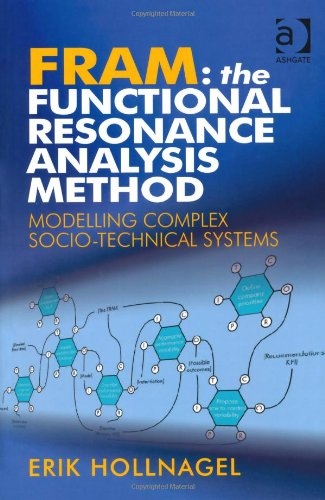Who is the author of this book?
Answer the question using a single word or phrase. Erik Hollnagel What is the title of this book? FRAM: The Functional Resonance Analysis Method: Modelling Complex Socio-technical Systems What type of book is this? Computers & Technology Is this book related to Computers & Technology? Yes Is this book related to Sports & Outdoors? No 